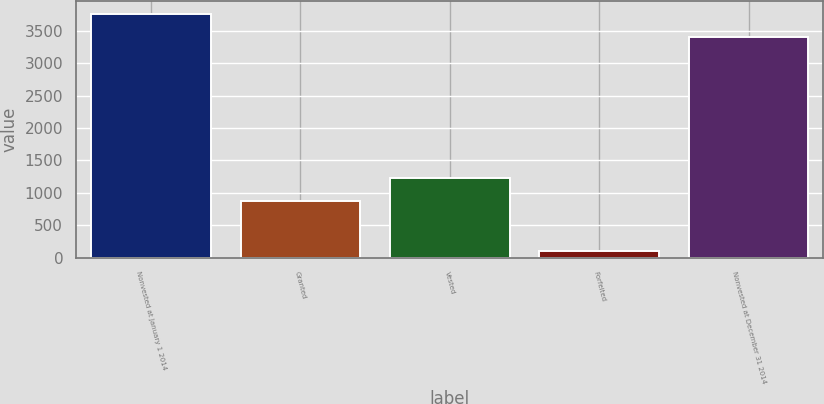<chart> <loc_0><loc_0><loc_500><loc_500><bar_chart><fcel>Nonvested at January 1 2014<fcel>Granted<fcel>Vested<fcel>Forfeited<fcel>Nonvested at December 31 2014<nl><fcel>3764.2<fcel>871<fcel>1232.2<fcel>100<fcel>3403<nl></chart> 